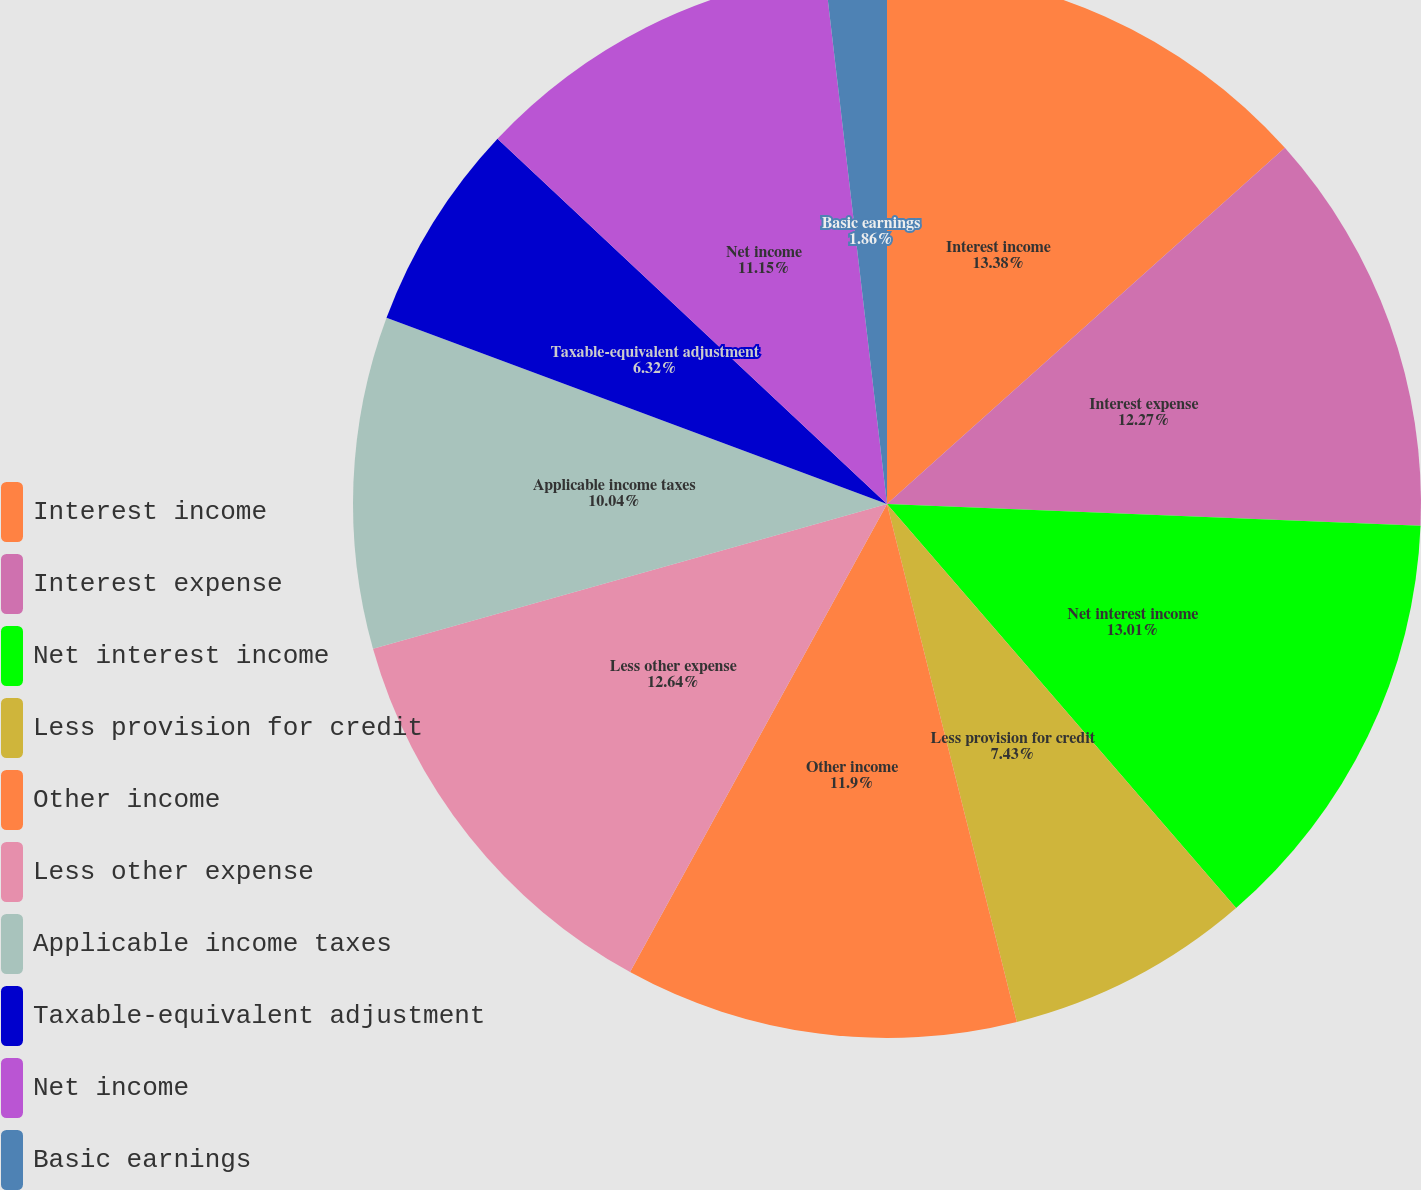Convert chart to OTSL. <chart><loc_0><loc_0><loc_500><loc_500><pie_chart><fcel>Interest income<fcel>Interest expense<fcel>Net interest income<fcel>Less provision for credit<fcel>Other income<fcel>Less other expense<fcel>Applicable income taxes<fcel>Taxable-equivalent adjustment<fcel>Net income<fcel>Basic earnings<nl><fcel>13.38%<fcel>12.27%<fcel>13.01%<fcel>7.43%<fcel>11.9%<fcel>12.64%<fcel>10.04%<fcel>6.32%<fcel>11.15%<fcel>1.86%<nl></chart> 